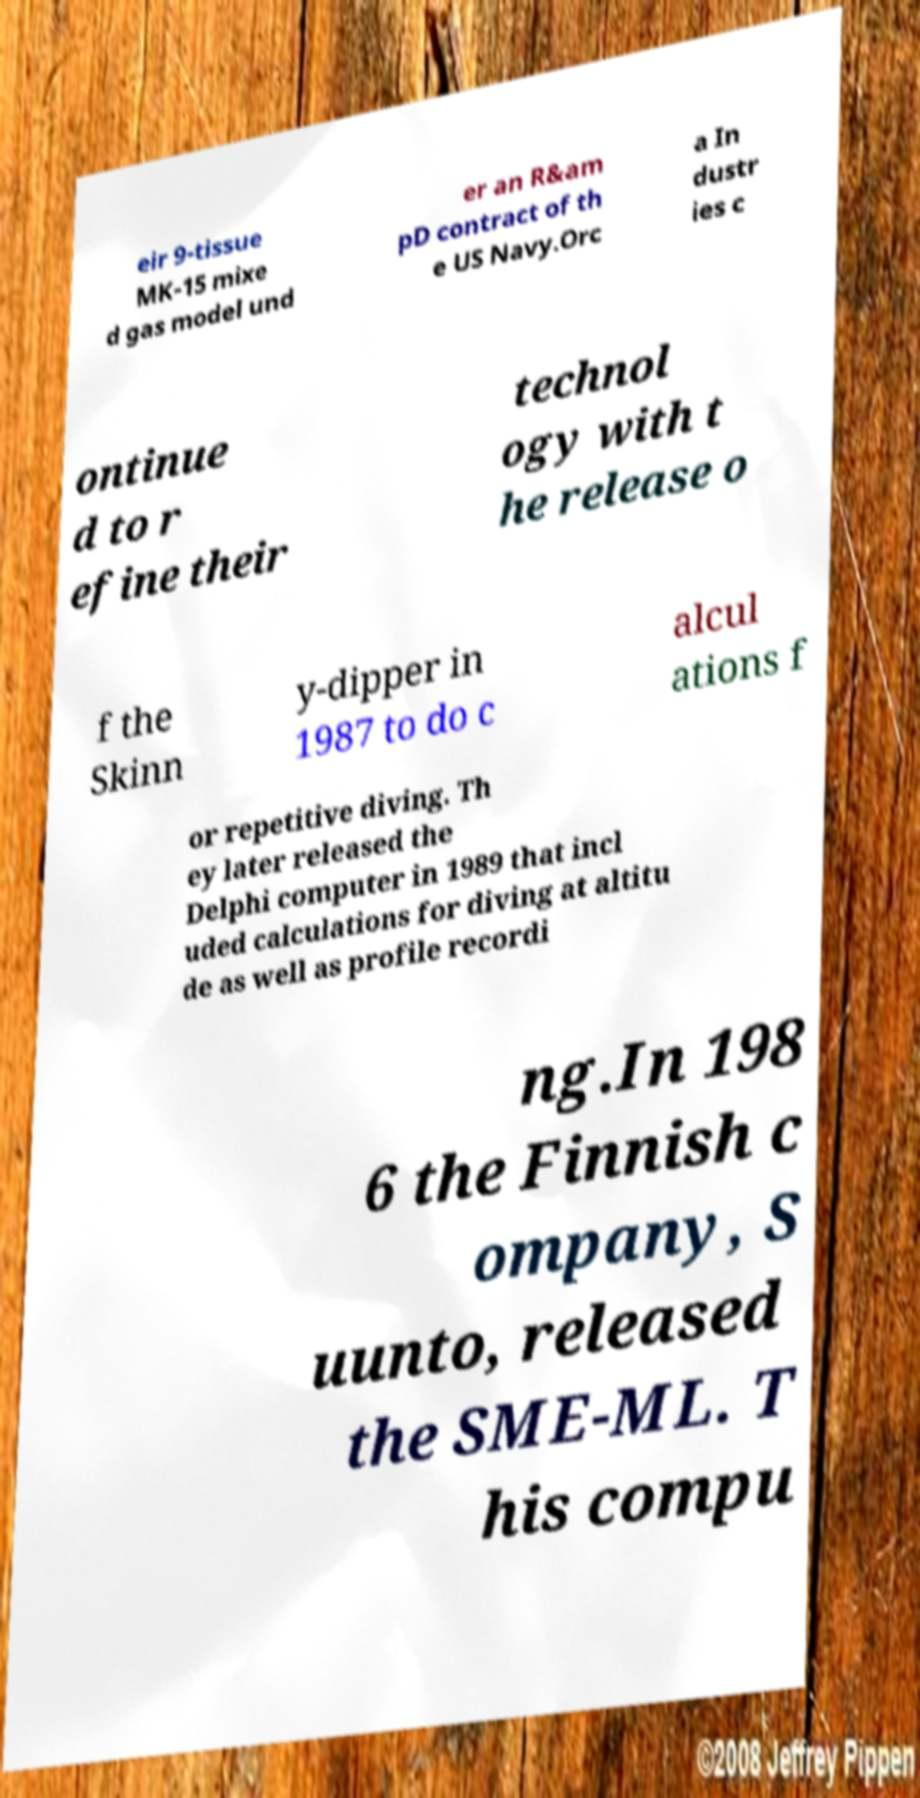Could you extract and type out the text from this image? eir 9-tissue MK-15 mixe d gas model und er an R&am pD contract of th e US Navy.Orc a In dustr ies c ontinue d to r efine their technol ogy with t he release o f the Skinn y-dipper in 1987 to do c alcul ations f or repetitive diving. Th ey later released the Delphi computer in 1989 that incl uded calculations for diving at altitu de as well as profile recordi ng.In 198 6 the Finnish c ompany, S uunto, released the SME-ML. T his compu 